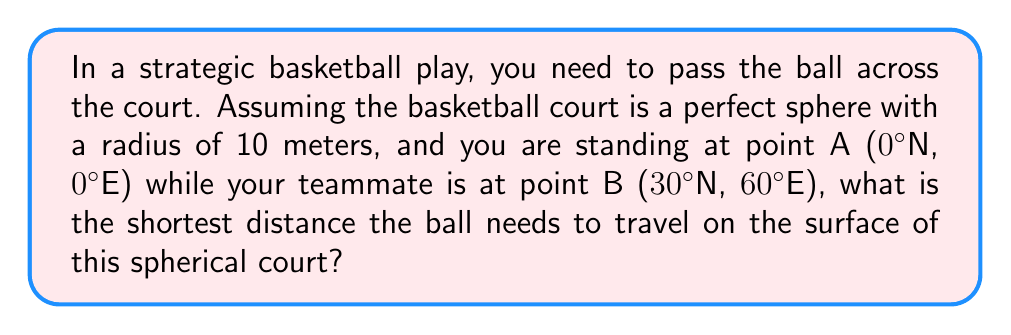Show me your answer to this math problem. To solve this problem, we need to use the great circle distance formula, which gives the shortest path between two points on a sphere. This concept is crucial in non-Euclidean geometry and can be applied to strategic gameplay on a curved surface.

Step 1: Convert the given coordinates to radians.
Latitude of A: $\phi_1 = 0° = 0$ radians
Longitude of A: $\lambda_1 = 0° = 0$ radians
Latitude of B: $\phi_2 = 30° = \frac{\pi}{6}$ radians
Longitude of B: $\lambda_2 = 60° = \frac{\pi}{3}$ radians

Step 2: Use the great circle distance formula:
$$d = r \cdot \arccos(\sin\phi_1 \sin\phi_2 + \cos\phi_1 \cos\phi_2 \cos(\lambda_2 - \lambda_1))$$

Where:
$r$ is the radius of the sphere (10 meters)
$d$ is the shortest distance between the two points

Step 3: Substitute the values into the formula:
$$d = 10 \cdot \arccos(\sin(0) \sin(\frac{\pi}{6}) + \cos(0) \cos(\frac{\pi}{6}) \cos(\frac{\pi}{3} - 0))$$

Step 4: Simplify:
$$d = 10 \cdot \arccos(0 \cdot \frac{1}{2} + 1 \cdot \frac{\sqrt{3}}{2} \cdot \frac{1}{2})$$
$$d = 10 \cdot \arccos(\frac{\sqrt{3}}{4})$$

Step 5: Calculate the result:
$$d \approx 10 \cdot 1.2490 \approx 12.49 \text{ meters}$$

This shortest path, known as a geodesic, represents the optimal trajectory for the ball to travel between the two players on the spherical court.
Answer: 12.49 meters 